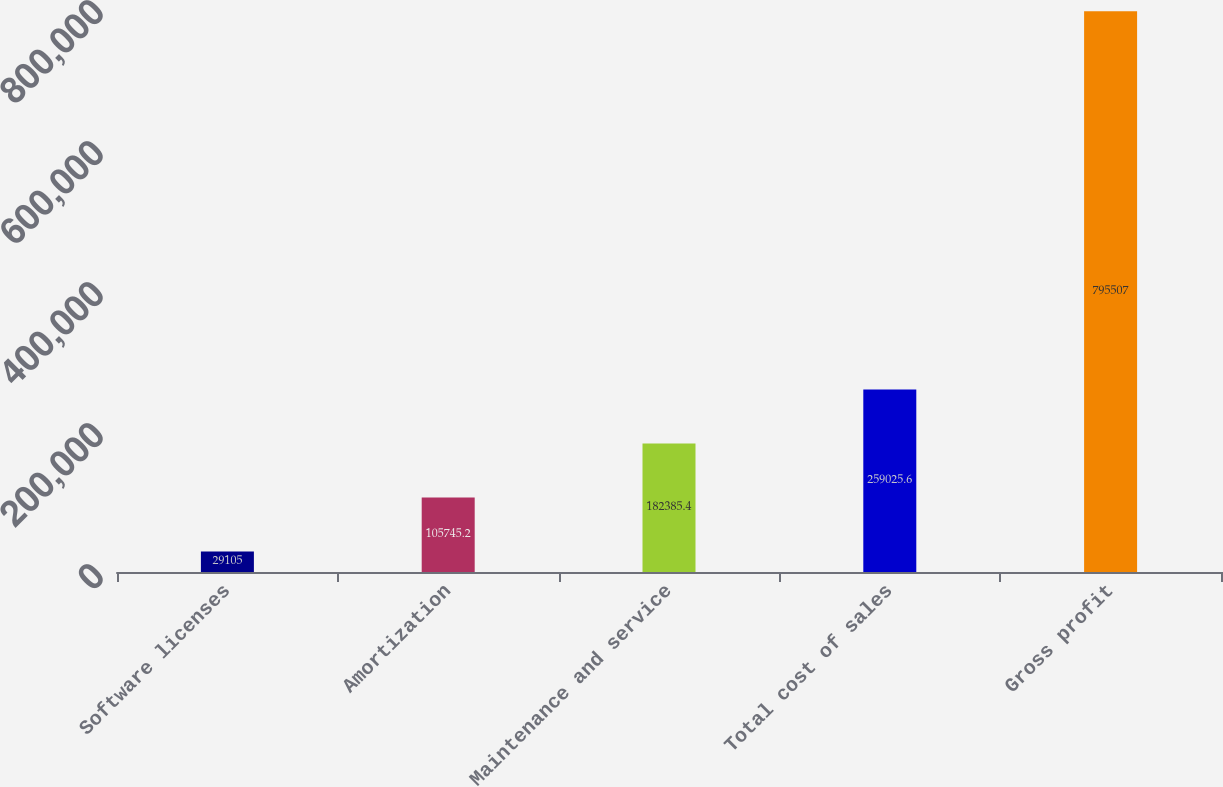Convert chart to OTSL. <chart><loc_0><loc_0><loc_500><loc_500><bar_chart><fcel>Software licenses<fcel>Amortization<fcel>Maintenance and service<fcel>Total cost of sales<fcel>Gross profit<nl><fcel>29105<fcel>105745<fcel>182385<fcel>259026<fcel>795507<nl></chart> 